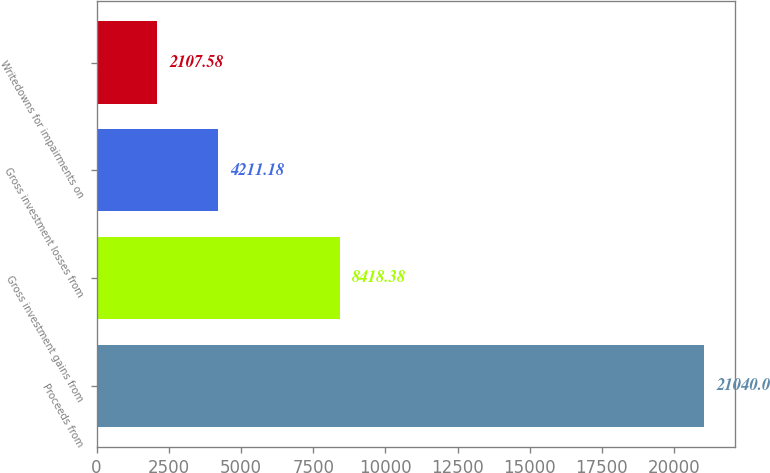Convert chart to OTSL. <chart><loc_0><loc_0><loc_500><loc_500><bar_chart><fcel>Proceeds from<fcel>Gross investment gains from<fcel>Gross investment losses from<fcel>Writedowns for impairments on<nl><fcel>21040<fcel>8418.38<fcel>4211.18<fcel>2107.58<nl></chart> 